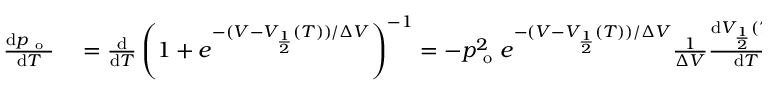Convert formula to latex. <formula><loc_0><loc_0><loc_500><loc_500>\begin{array} { r l } { \frac { d p _ { o } } { d T } } & = \frac { d } { d T } \left ( 1 + e ^ { - ( V - V _ { \frac { 1 } { 2 } } ( T ) ) / \Delta V } \right ) ^ { - 1 } = - p _ { o } ^ { 2 } e ^ { - ( V - V _ { \frac { 1 } { 2 } } ( T ) ) / \Delta V } \frac { 1 } { \Delta V } \frac { d V _ { \frac { 1 } { 2 } } ( T ) } { d T } = } \end{array}</formula> 